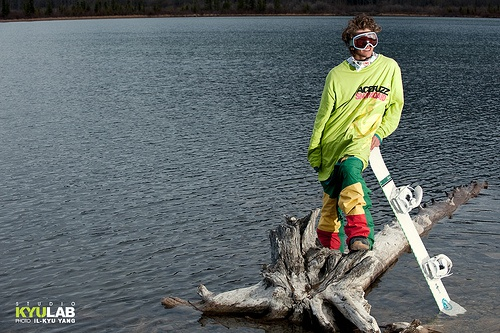Describe the objects in this image and their specific colors. I can see people in black, khaki, and olive tones and snowboard in black, ivory, darkgray, gray, and lightgray tones in this image. 